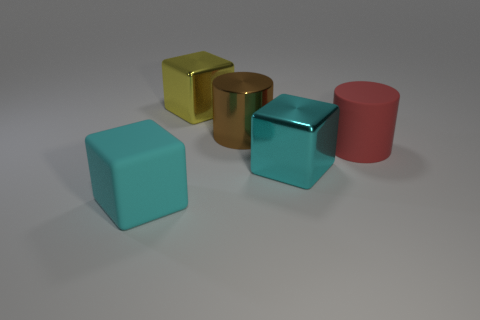There is a large rubber cylinder; are there any big cyan matte cubes to the left of it?
Make the answer very short. Yes. There is a matte object right of the big cyan rubber block; are there any yellow cubes that are to the left of it?
Provide a short and direct response. Yes. Is the number of large matte cylinders in front of the rubber cylinder less than the number of cyan objects that are on the left side of the big brown shiny thing?
Make the answer very short. Yes. What shape is the red object?
Keep it short and to the point. Cylinder. There is a cylinder right of the brown thing; what is it made of?
Make the answer very short. Rubber. Do the large cube that is behind the big cyan shiny object and the large brown object left of the red rubber cylinder have the same material?
Give a very brief answer. Yes. How many other things are there of the same color as the big matte cylinder?
Your answer should be compact. 0. How many objects are matte things that are right of the large brown cylinder or large metallic blocks that are to the left of the large metal cylinder?
Make the answer very short. 2. There is a cyan block left of the large metal block that is in front of the big brown cylinder; what is its size?
Offer a terse response. Large. There is a matte thing left of the big brown metallic thing; does it have the same color as the big metal cube that is in front of the red object?
Your answer should be compact. Yes. 